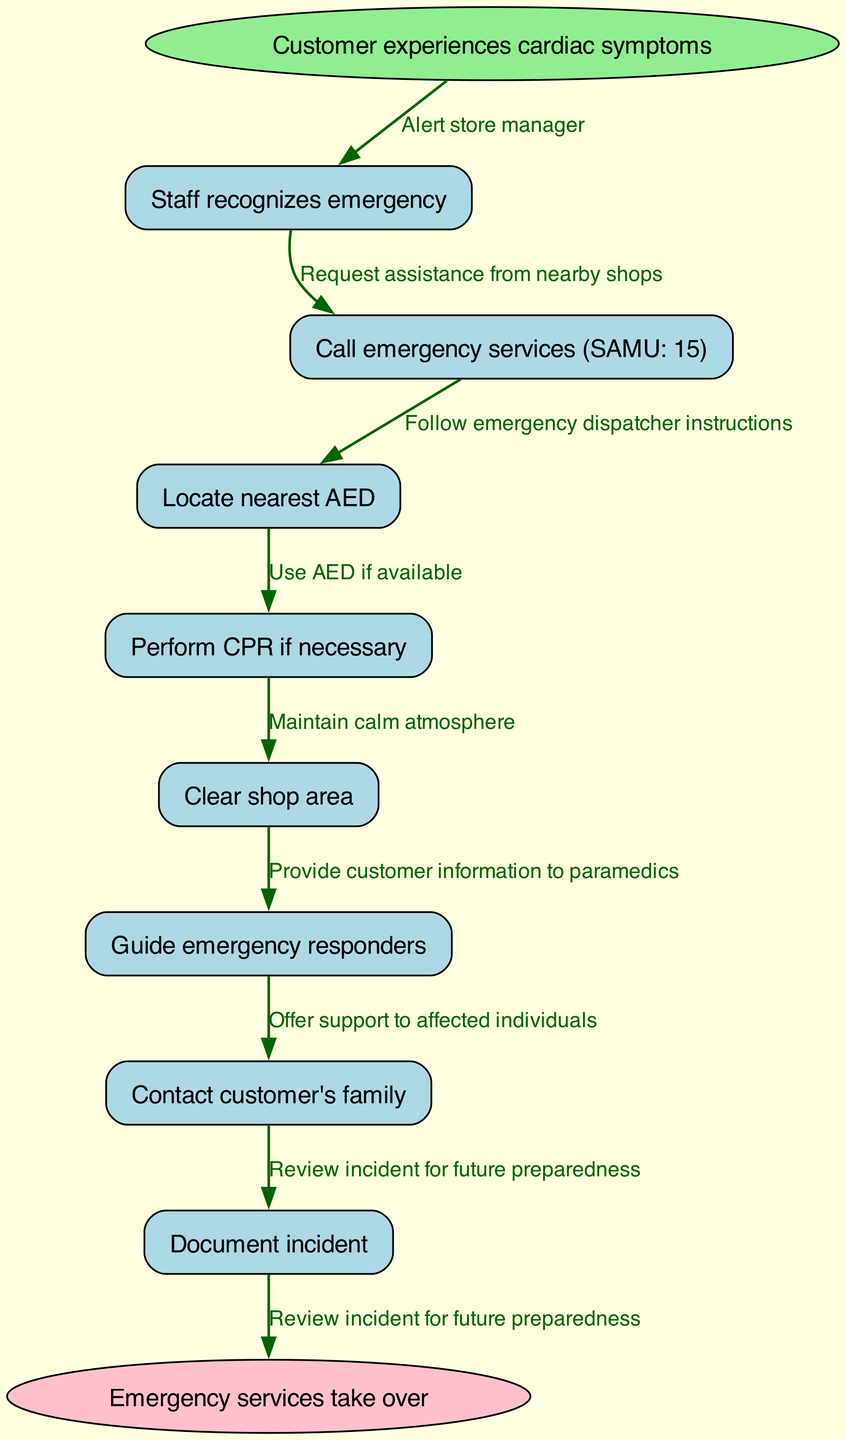What is the starting point of the pathway? The diagram indicates that the pathway starts when a customer experiences cardiac symptoms. This is the first event described and sets the stage for the subsequent actions in the pathway.
Answer: Customer experiences cardiac symptoms How many nodes are there in the pathway? The diagram lists a total of 8 nodes, including the starting and ending points. The nodes represent various actions and decisions taken in response to a cardiac event, leading to the conclusion of the pathway.
Answer: 8 What action follows after the staff recognizes an emergency? According to the diagram, following the recognition of an emergency by the staff, the next action is to call emergency services (SAMU: 15). This sequence is clearly outlined to ensure immediate assistance is sought.
Answer: Call emergency services (SAMU: 15) What is the last step in the emergency response pathway? The last step in the pathway, as shown in the diagram, is when emergency services take over. This indicates the transition from store staff handling the situation to professional responders taking charge of the emergency.
Answer: Emergency services take over How many edges are connecting the nodes in the pathway? The diagram illustrates that there are 8 edges connecting the nodes. These edges describe the relationships and transitions between different actions within the emergency response process.
Answer: 8 What happens during the "Guide emergency responders" step? During the "Guide emergency responders" step, store staff are responsible for directing the paramedics to the location of the customer in need. This is crucial for ensuring a swift response and aiding those in critical situations.
Answer: Guide emergency responders What is the action taken before the AED is used? Prior to using the AED, the staff must locate the nearest AED. This action is vital as it involves preparing the necessary equipment for potential defibrillation during a cardiac event.
Answer: Locate nearest AED What edge connects "Perform CPR if necessary" to the next action? The edge that connects "Perform CPR if necessary" to the next action is indicated by the label that reads "Use AED if available." This demonstrates a logical sequence where CPR might be followed by the application of the AED should it be accessible.
Answer: Use AED if available 